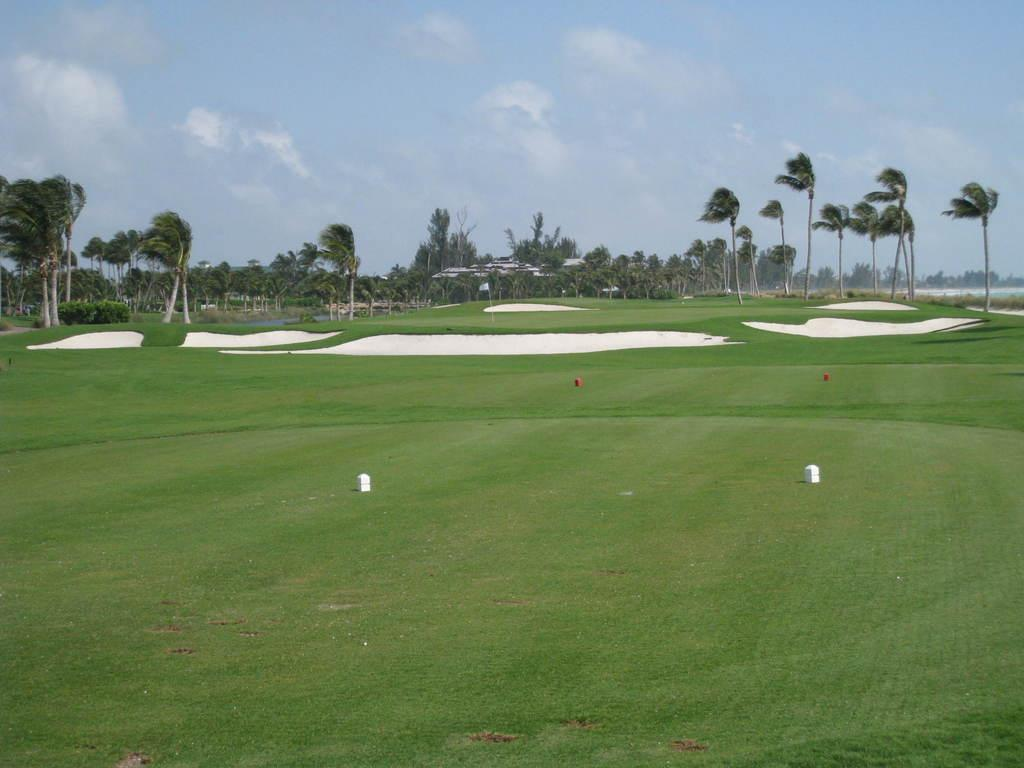Where was the image taken? The image was taken in a ground. What type of vegetation can be seen on the ground? There is grass on the ground. What other objects are present on the ground? There are poles on the ground. What can be seen in the background of the image? Trees and the sky are visible in the image. What is the name of the cracker that is being held by the person in the image? There is no person holding a cracker in the image. What type of flag is visible in the image? There is no flag present in the image. 